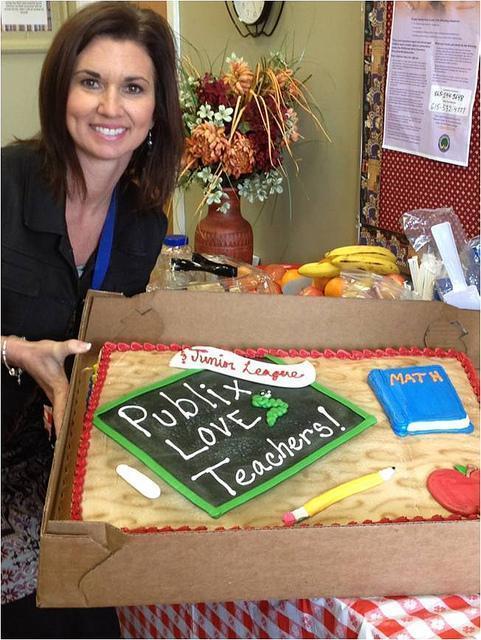Does the image validate the caption "The person is part of the cake."?
Answer yes or no. No. Is this affirmation: "The cake is near the banana." correct?
Answer yes or no. Yes. 